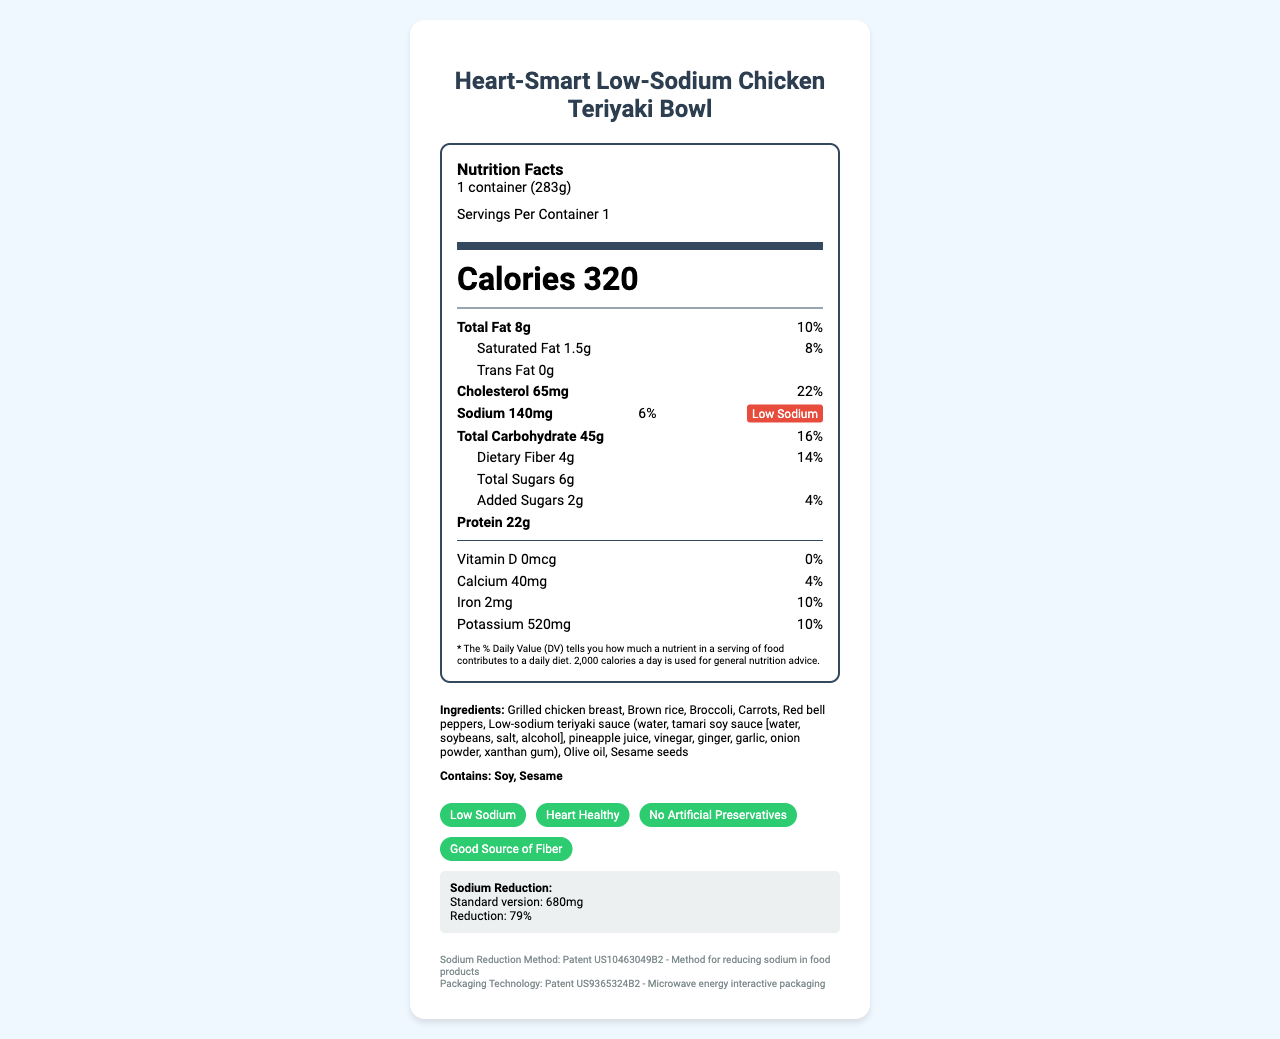what is the serving size? The serving size is listed as "1 container (283g)" in the label's header.
Answer: 1 container (283g) how many calories are there per serving? The label shows the Calories per serving value as 320 right below the serving information.
Answer: 320 what is the amount of sodium per serving? The sodium content per serving is listed as 140mg in the nutrition facts section.
Answer: 140mg what ingredients are used in the meal? The ingredients list includes Grilled chicken breast, Brown rice, Broccoli, Carrots, Red bell peppers, Low-sodium teriyaki sauce, Olive oil, and Sesame seeds.
Answer: Grilled chicken breast, Brown rice, Broccoli, Carrots, Red bell peppers, Low-sodium teriyaki sauce, Olive oil, Sesame seeds what is the percentage daily value of dietary fiber? The daily value percentage for dietary fiber is indicated as 14% next to the nutrient amount.
Answer: 14% how much saturated fat is in one serving? The amount of saturated fat per serving is 1.5g as shown in the sub-nutrient section below Total Fat.
Answer: 1.5g what certifications does the product have? The claims and certifications section lists these four certifications.
Answer: Low Sodium, Heart Healthy, No Artificial Preservatives, Good Source of Fiber what is the cholesterol content per serving? A. 20mg B. 55mg C. 65mg D. 85mg The cholesterol content per serving is 65mg, as indicated in the nutrition facts section.
Answer: C. 65mg what is the total carbohydrate content? A. 40g B. 45g C. 30g D. 50g The total carbohydrate content is listed as 45g in the nutrition facts section.
Answer: B. 45g is this product high in trans fat? The label indicates that the trans fat content is 0g, which means there is no trans fat in the product.
Answer: No does the product contain any allergens? It contains Soy and Sesame as highlighted in the allergens section.
Answer: Yes describe the main benefits highlighted on the label. These benefits are specified in the claims section and the heart-healthy features listed.
Answer: The product emphasizes being low in sodium, heart-healthy, and a good source of fiber. It contains no artificial preservatives and uses heart-healthy olive oil. what is the method used for reducing sodium in the product? The label mentions that a specific method (Patent US10463049B2) is used for reducing sodium, but the details of this method are not provided in the label.
Answer: Cannot be determined how much potassium is in one serving? The potassium content per serving is indicated as 520mg in the nutrition facts section.
Answer: 520mg what is the sodium reduction percentage compared to the standard version? The comparison section shows that the sodium reduction compared to the standard version is 79%.
Answer: 79% 